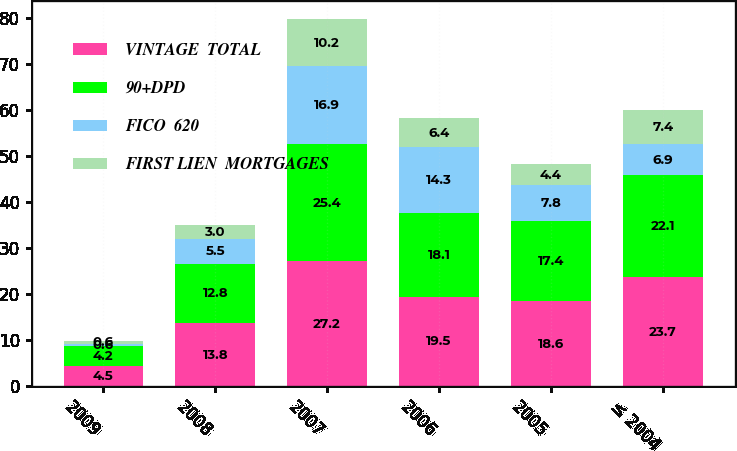Convert chart to OTSL. <chart><loc_0><loc_0><loc_500><loc_500><stacked_bar_chart><ecel><fcel>2009<fcel>2008<fcel>2007<fcel>2006<fcel>2005<fcel>≤ 2004<nl><fcel>VINTAGE  TOTAL<fcel>4.5<fcel>13.8<fcel>27.2<fcel>19.5<fcel>18.6<fcel>23.7<nl><fcel>90+DPD<fcel>4.2<fcel>12.8<fcel>25.4<fcel>18.1<fcel>17.4<fcel>22.1<nl><fcel>FICO  620<fcel>0.6<fcel>5.5<fcel>16.9<fcel>14.3<fcel>7.8<fcel>6.9<nl><fcel>FIRST LIEN  MORTGAGES<fcel>0.6<fcel>3<fcel>10.2<fcel>6.4<fcel>4.4<fcel>7.4<nl></chart> 